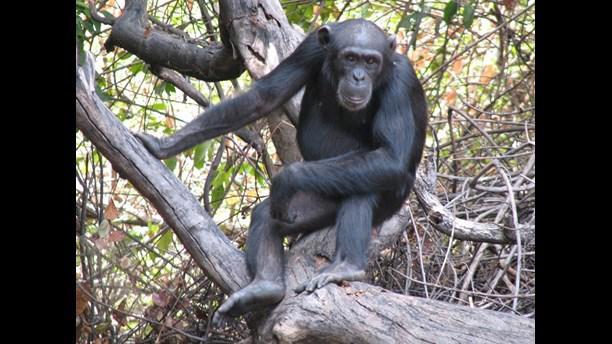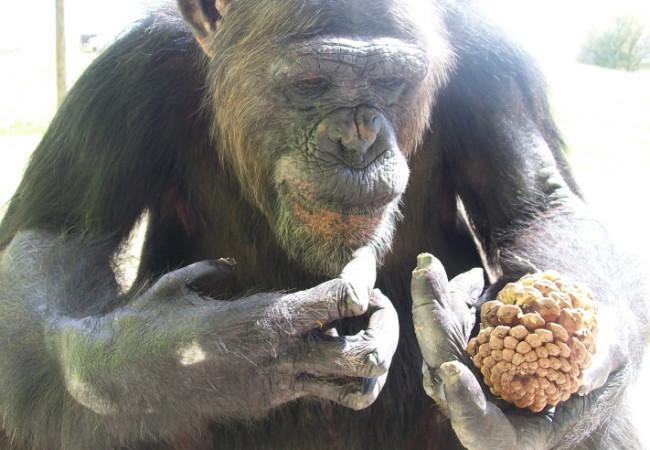The first image is the image on the left, the second image is the image on the right. Evaluate the accuracy of this statement regarding the images: "There are a total of 5 monkeys present outside.". Is it true? Answer yes or no. No. The first image is the image on the left, the second image is the image on the right. For the images displayed, is the sentence "In one image there is a single chimpanzee and in the other there is a group of at least four." factually correct? Answer yes or no. No. 